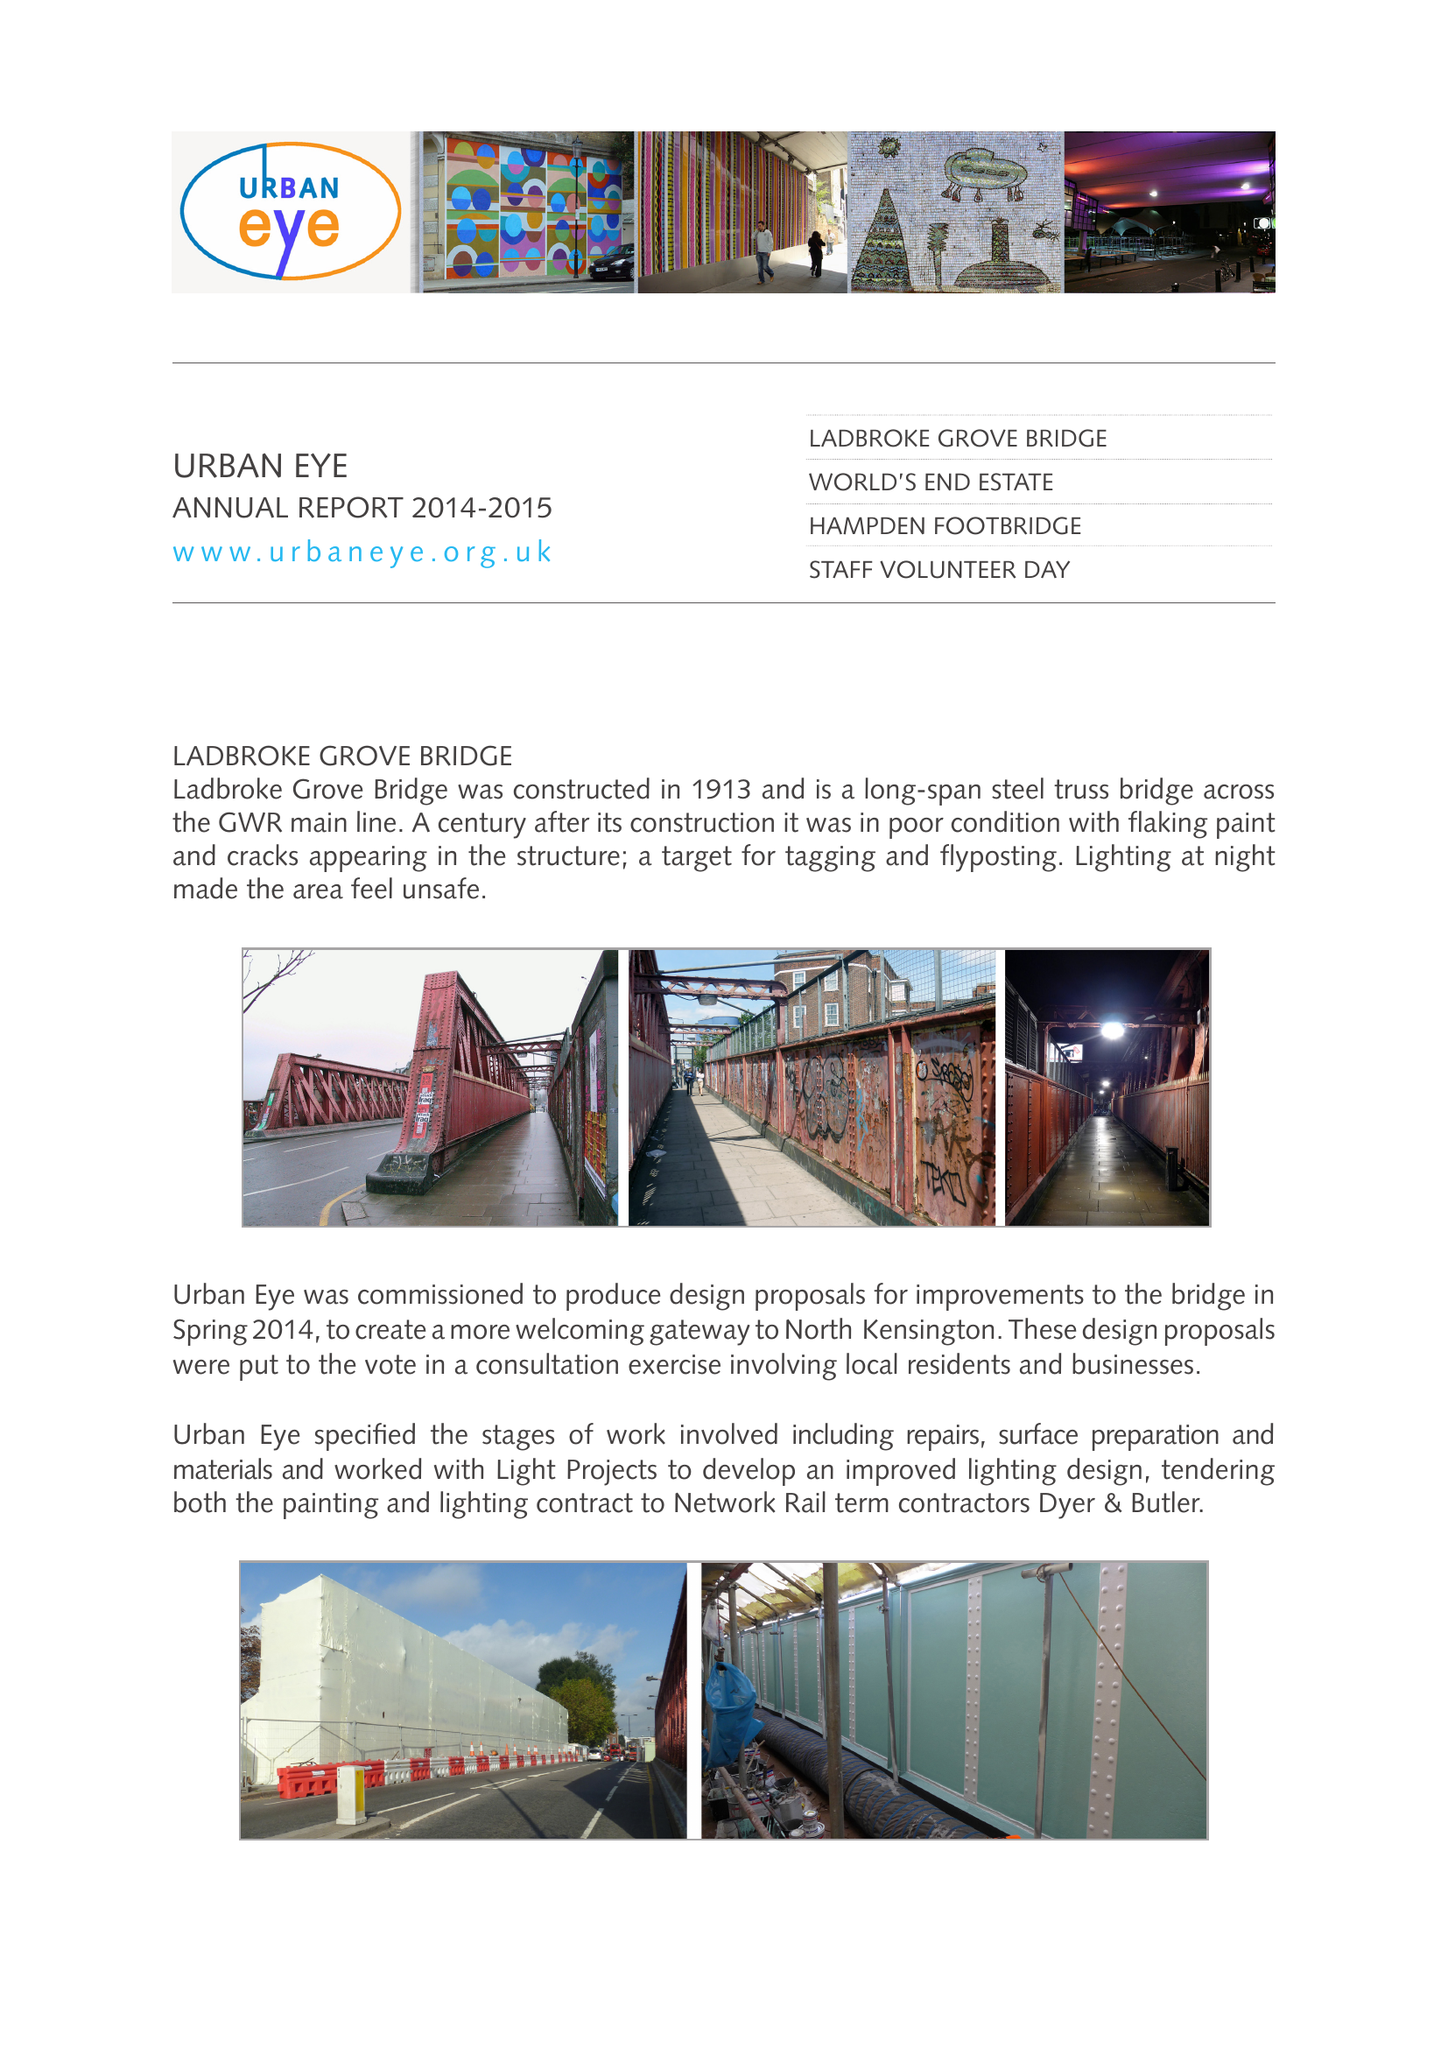What is the value for the charity_number?
Answer the question using a single word or phrase. 1089336 